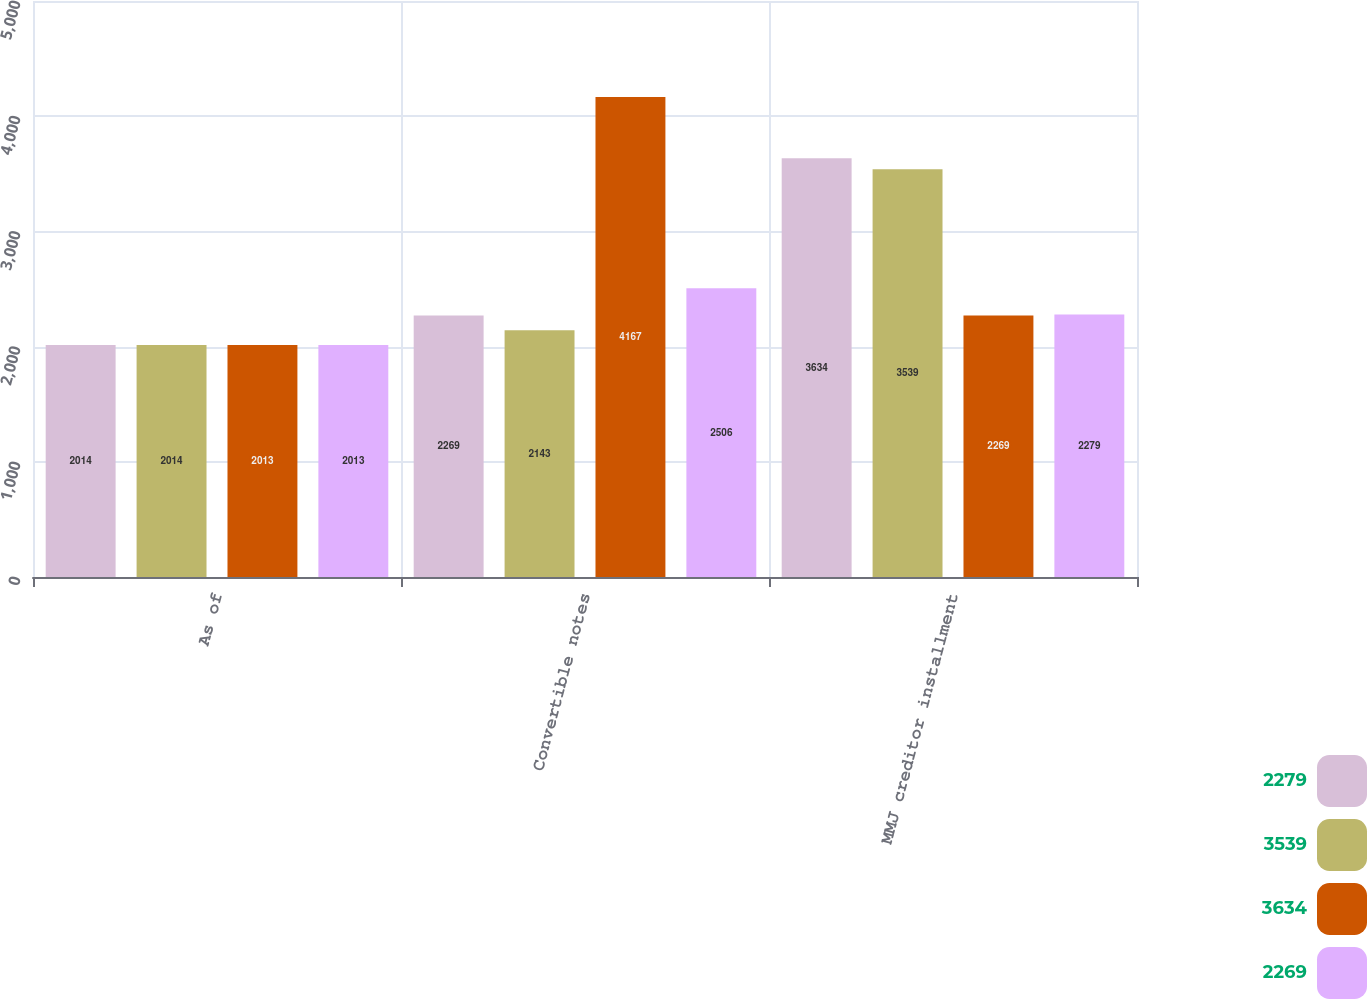Convert chart to OTSL. <chart><loc_0><loc_0><loc_500><loc_500><stacked_bar_chart><ecel><fcel>As of<fcel>Convertible notes<fcel>MMJ creditor installment<nl><fcel>2279<fcel>2014<fcel>2269<fcel>3634<nl><fcel>3539<fcel>2014<fcel>2143<fcel>3539<nl><fcel>3634<fcel>2013<fcel>4167<fcel>2269<nl><fcel>2269<fcel>2013<fcel>2506<fcel>2279<nl></chart> 